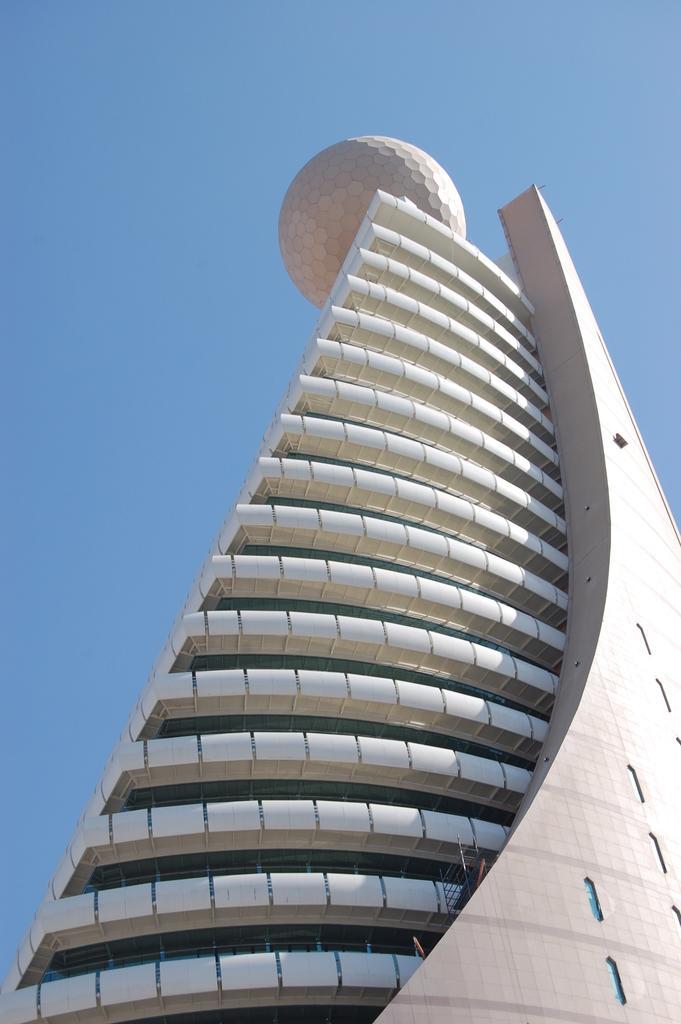How would you summarize this image in a sentence or two? In this picture there is a skyscrapers in the center of the image, there is a circle model at the top of it. 